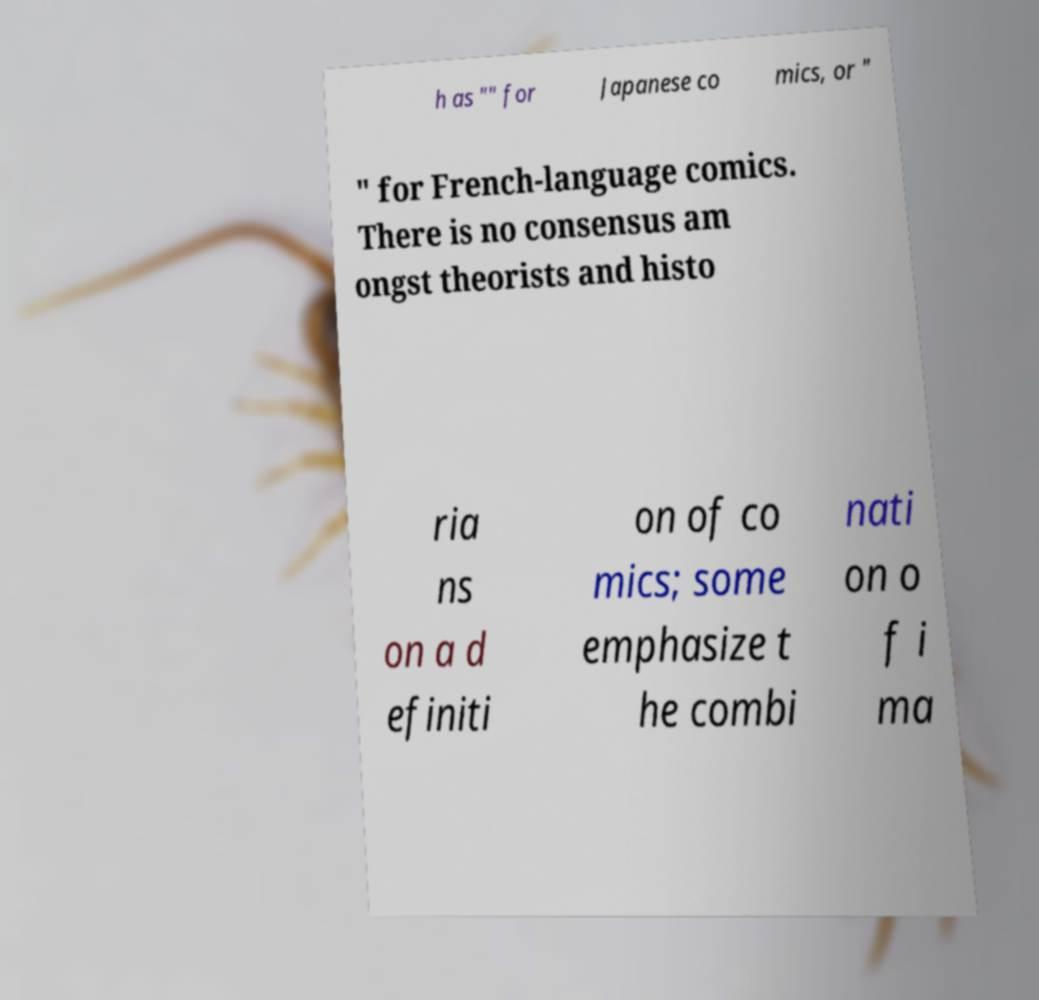Please read and relay the text visible in this image. What does it say? h as "" for Japanese co mics, or " " for French-language comics. There is no consensus am ongst theorists and histo ria ns on a d efiniti on of co mics; some emphasize t he combi nati on o f i ma 